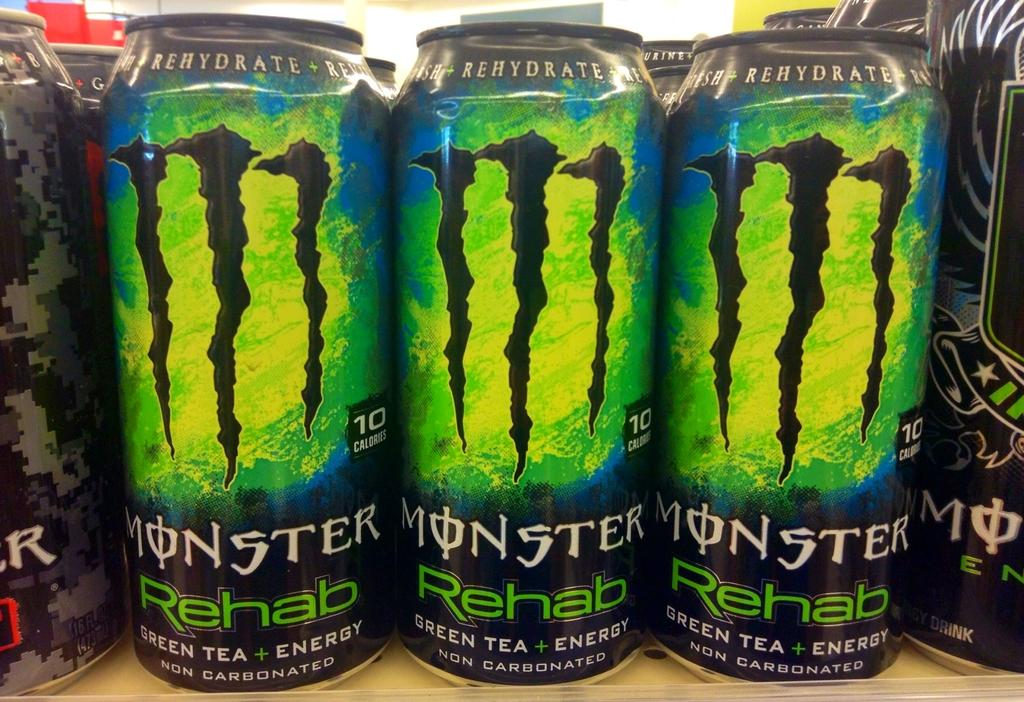<image>
Give a short and clear explanation of the subsequent image. Cans of Monster energy drinks line a shelf. 